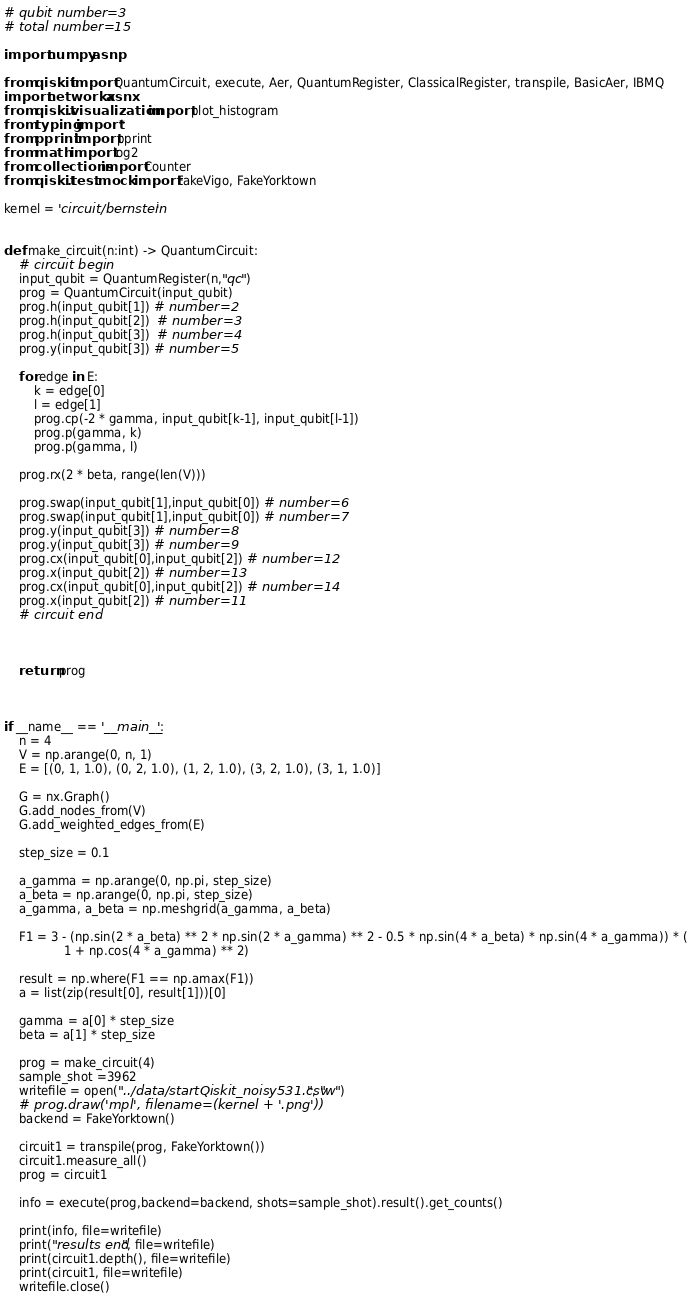<code> <loc_0><loc_0><loc_500><loc_500><_Python_># qubit number=3
# total number=15

import numpy as np

from qiskit import QuantumCircuit, execute, Aer, QuantumRegister, ClassicalRegister, transpile, BasicAer, IBMQ
import networkx as nx
from qiskit.visualization import plot_histogram
from typing import *
from pprint import pprint
from math import log2
from collections import Counter
from qiskit.test.mock import FakeVigo, FakeYorktown

kernel = 'circuit/bernstein'


def make_circuit(n:int) -> QuantumCircuit:
    # circuit begin
    input_qubit = QuantumRegister(n,"qc")
    prog = QuantumCircuit(input_qubit)
    prog.h(input_qubit[1]) # number=2
    prog.h(input_qubit[2])  # number=3
    prog.h(input_qubit[3])  # number=4
    prog.y(input_qubit[3]) # number=5

    for edge in E:
        k = edge[0]
        l = edge[1]
        prog.cp(-2 * gamma, input_qubit[k-1], input_qubit[l-1])
        prog.p(gamma, k)
        prog.p(gamma, l)

    prog.rx(2 * beta, range(len(V)))

    prog.swap(input_qubit[1],input_qubit[0]) # number=6
    prog.swap(input_qubit[1],input_qubit[0]) # number=7
    prog.y(input_qubit[3]) # number=8
    prog.y(input_qubit[3]) # number=9
    prog.cx(input_qubit[0],input_qubit[2]) # number=12
    prog.x(input_qubit[2]) # number=13
    prog.cx(input_qubit[0],input_qubit[2]) # number=14
    prog.x(input_qubit[2]) # number=11
    # circuit end



    return prog



if __name__ == '__main__':
    n = 4
    V = np.arange(0, n, 1)
    E = [(0, 1, 1.0), (0, 2, 1.0), (1, 2, 1.0), (3, 2, 1.0), (3, 1, 1.0)]

    G = nx.Graph()
    G.add_nodes_from(V)
    G.add_weighted_edges_from(E)

    step_size = 0.1

    a_gamma = np.arange(0, np.pi, step_size)
    a_beta = np.arange(0, np.pi, step_size)
    a_gamma, a_beta = np.meshgrid(a_gamma, a_beta)

    F1 = 3 - (np.sin(2 * a_beta) ** 2 * np.sin(2 * a_gamma) ** 2 - 0.5 * np.sin(4 * a_beta) * np.sin(4 * a_gamma)) * (
                1 + np.cos(4 * a_gamma) ** 2)

    result = np.where(F1 == np.amax(F1))
    a = list(zip(result[0], result[1]))[0]

    gamma = a[0] * step_size
    beta = a[1] * step_size

    prog = make_circuit(4)
    sample_shot =3962
    writefile = open("../data/startQiskit_noisy531.csv", "w")
    # prog.draw('mpl', filename=(kernel + '.png'))
    backend = FakeYorktown()

    circuit1 = transpile(prog, FakeYorktown())
    circuit1.measure_all()
    prog = circuit1

    info = execute(prog,backend=backend, shots=sample_shot).result().get_counts()

    print(info, file=writefile)
    print("results end", file=writefile)
    print(circuit1.depth(), file=writefile)
    print(circuit1, file=writefile)
    writefile.close()
</code> 